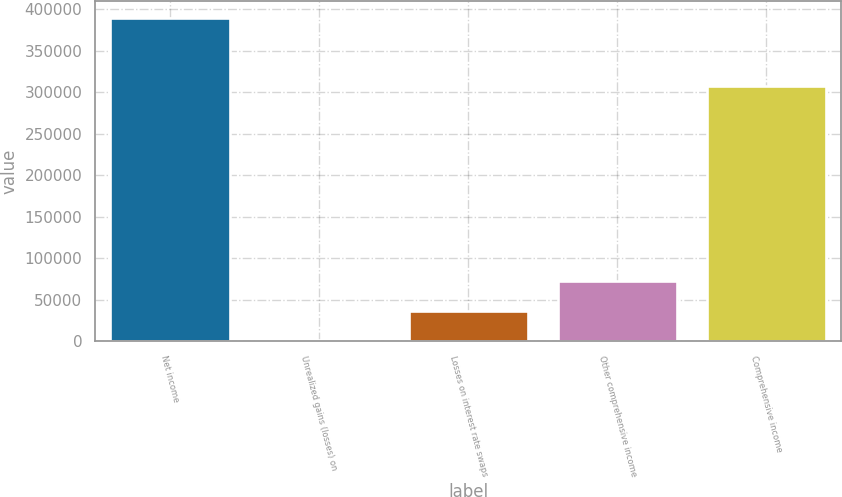Convert chart. <chart><loc_0><loc_0><loc_500><loc_500><bar_chart><fcel>Net income<fcel>Unrealized gains (losses) on<fcel>Losses on interest rate swaps<fcel>Other comprehensive income<fcel>Comprehensive income<nl><fcel>389790<fcel>1192<fcel>36683.9<fcel>72175.8<fcel>307395<nl></chart> 